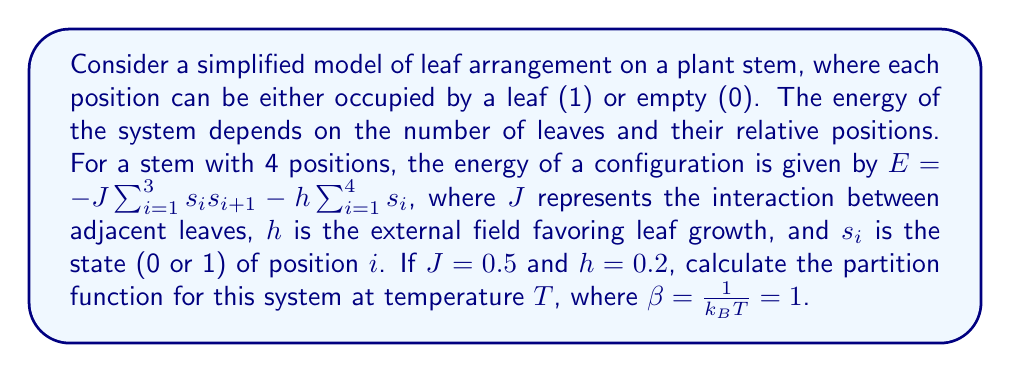Can you solve this math problem? Let's approach this step-by-step:

1) The partition function is given by:
   $$Z = \sum_{\text{all states}} e^{-\beta E}$$

2) For a system with 4 positions, we have $2^4 = 16$ possible configurations.

3) We need to calculate the energy for each configuration and sum up $e^{-E}$ (since $\beta = 1$).

4) Let's calculate for a few configurations:

   a) For [0000]: $E = 0$, so contribution is $e^0 = 1$
   
   b) For [1000]: $E = -0.2$, so contribution is $e^{0.2} \approx 1.2214$
   
   c) For [1100]: $E = -0.5 - 0.4 = -0.9$, so contribution is $e^{0.9} \approx 2.4596$

5) We need to do this for all 16 configurations. Here's a list of all configurations and their contributions:

   [0000]: 1.0000
   [0001], [0010], [0100], [1000]: 1.2214 each
   [0011], [0110], [1100]: 2.4596 each
   [0101], [1001], [1010]: 1.4918 each
   [0111], [1011], [1101], [1110]: 3.0042 each
   [1111]: 3.6693

6) Sum up all these contributions:

   $$Z = 1.0000 + 4(1.2214) + 3(2.4596) + 3(1.4918) + 4(3.0042) + 3.6693$$

7) Calculating this sum:

   $$Z = 1.0000 + 4.8856 + 7.3788 + 4.4754 + 12.0168 + 3.6693 = 33.4259$$
Answer: $Z \approx 33.4259$ 